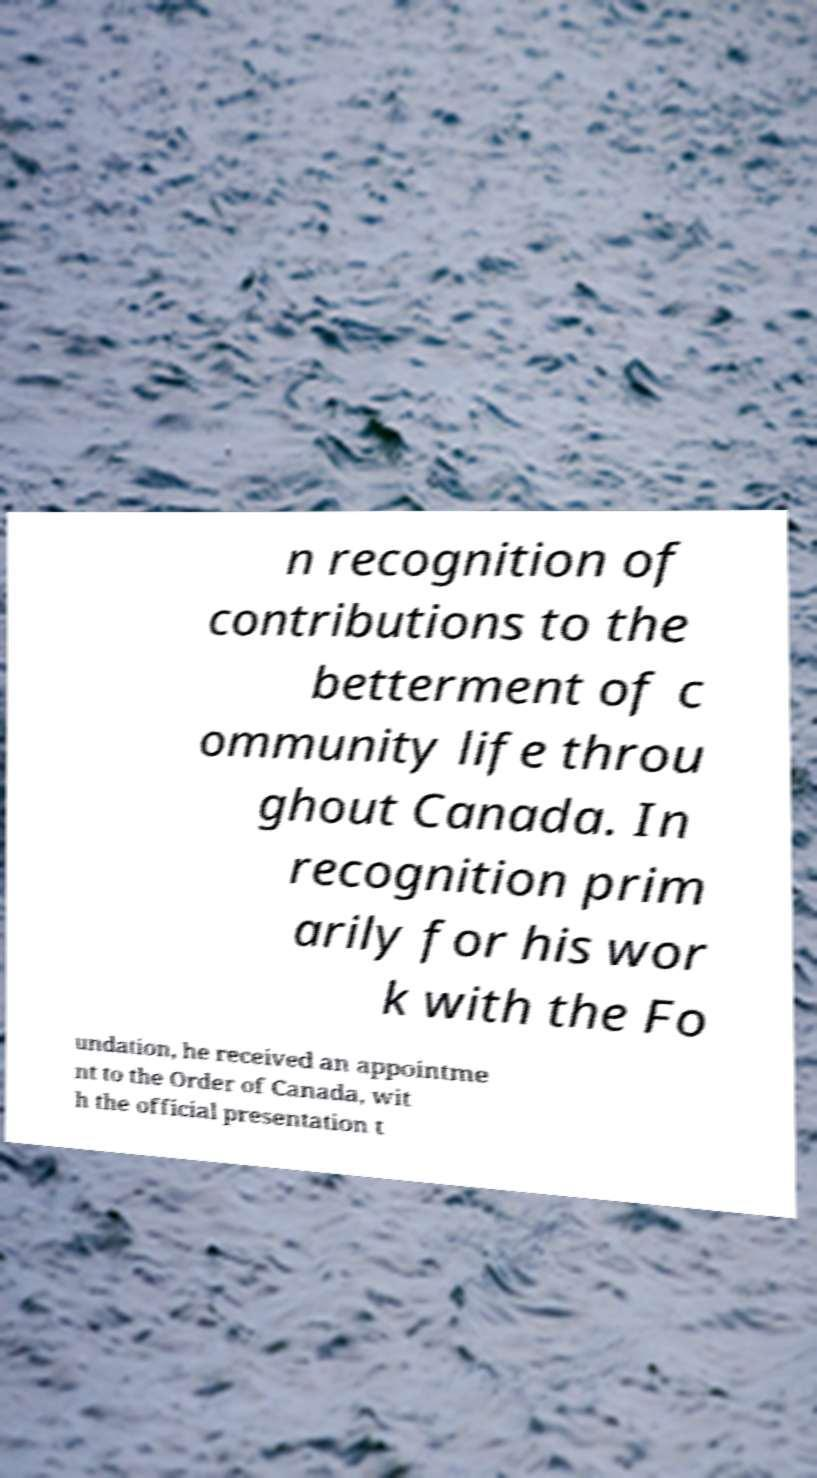What messages or text are displayed in this image? I need them in a readable, typed format. n recognition of contributions to the betterment of c ommunity life throu ghout Canada. In recognition prim arily for his wor k with the Fo undation, he received an appointme nt to the Order of Canada, wit h the official presentation t 